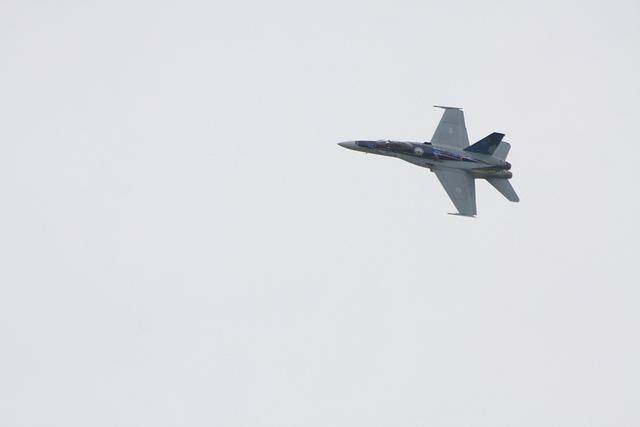Where is the aircraft?
Answer briefly. In air. What kind of aircraft is this?
Be succinct. Jet. Is this moving fast?
Write a very short answer. Yes. How many jets are here?
Quick response, please. 1. Does this plane have a lot of G-force?
Give a very brief answer. Yes. Are we looking at the top or bottom of the jet?
Write a very short answer. Top. How many planes are there?
Write a very short answer. 1. 